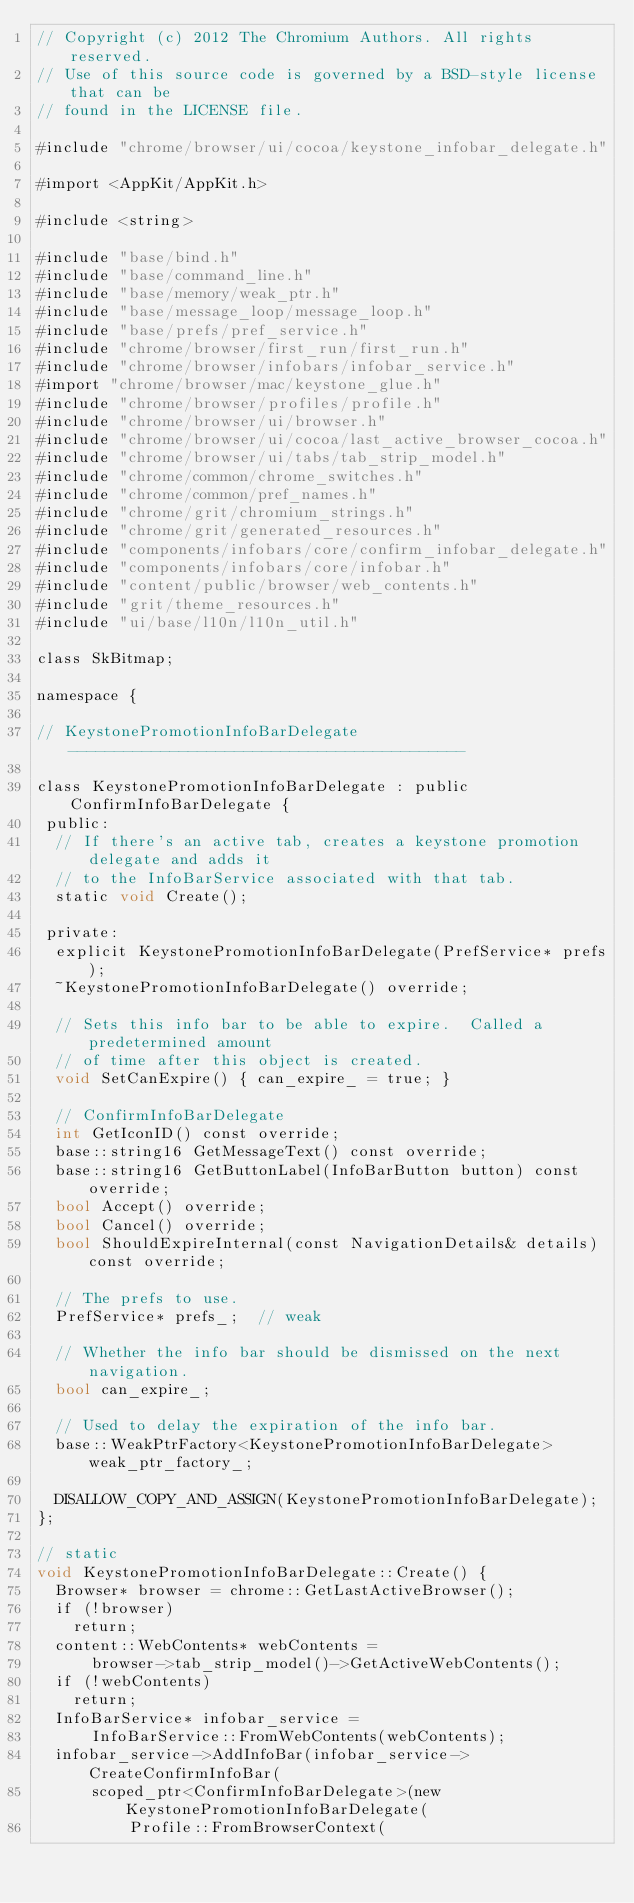<code> <loc_0><loc_0><loc_500><loc_500><_ObjectiveC_>// Copyright (c) 2012 The Chromium Authors. All rights reserved.
// Use of this source code is governed by a BSD-style license that can be
// found in the LICENSE file.

#include "chrome/browser/ui/cocoa/keystone_infobar_delegate.h"

#import <AppKit/AppKit.h>

#include <string>

#include "base/bind.h"
#include "base/command_line.h"
#include "base/memory/weak_ptr.h"
#include "base/message_loop/message_loop.h"
#include "base/prefs/pref_service.h"
#include "chrome/browser/first_run/first_run.h"
#include "chrome/browser/infobars/infobar_service.h"
#import "chrome/browser/mac/keystone_glue.h"
#include "chrome/browser/profiles/profile.h"
#include "chrome/browser/ui/browser.h"
#include "chrome/browser/ui/cocoa/last_active_browser_cocoa.h"
#include "chrome/browser/ui/tabs/tab_strip_model.h"
#include "chrome/common/chrome_switches.h"
#include "chrome/common/pref_names.h"
#include "chrome/grit/chromium_strings.h"
#include "chrome/grit/generated_resources.h"
#include "components/infobars/core/confirm_infobar_delegate.h"
#include "components/infobars/core/infobar.h"
#include "content/public/browser/web_contents.h"
#include "grit/theme_resources.h"
#include "ui/base/l10n/l10n_util.h"

class SkBitmap;

namespace {

// KeystonePromotionInfoBarDelegate -------------------------------------------

class KeystonePromotionInfoBarDelegate : public ConfirmInfoBarDelegate {
 public:
  // If there's an active tab, creates a keystone promotion delegate and adds it
  // to the InfoBarService associated with that tab.
  static void Create();

 private:
  explicit KeystonePromotionInfoBarDelegate(PrefService* prefs);
  ~KeystonePromotionInfoBarDelegate() override;

  // Sets this info bar to be able to expire.  Called a predetermined amount
  // of time after this object is created.
  void SetCanExpire() { can_expire_ = true; }

  // ConfirmInfoBarDelegate
  int GetIconID() const override;
  base::string16 GetMessageText() const override;
  base::string16 GetButtonLabel(InfoBarButton button) const override;
  bool Accept() override;
  bool Cancel() override;
  bool ShouldExpireInternal(const NavigationDetails& details) const override;

  // The prefs to use.
  PrefService* prefs_;  // weak

  // Whether the info bar should be dismissed on the next navigation.
  bool can_expire_;

  // Used to delay the expiration of the info bar.
  base::WeakPtrFactory<KeystonePromotionInfoBarDelegate> weak_ptr_factory_;

  DISALLOW_COPY_AND_ASSIGN(KeystonePromotionInfoBarDelegate);
};

// static
void KeystonePromotionInfoBarDelegate::Create() {
  Browser* browser = chrome::GetLastActiveBrowser();
  if (!browser)
    return;
  content::WebContents* webContents =
      browser->tab_strip_model()->GetActiveWebContents();
  if (!webContents)
    return;
  InfoBarService* infobar_service =
      InfoBarService::FromWebContents(webContents);
  infobar_service->AddInfoBar(infobar_service->CreateConfirmInfoBar(
      scoped_ptr<ConfirmInfoBarDelegate>(new KeystonePromotionInfoBarDelegate(
          Profile::FromBrowserContext(</code> 